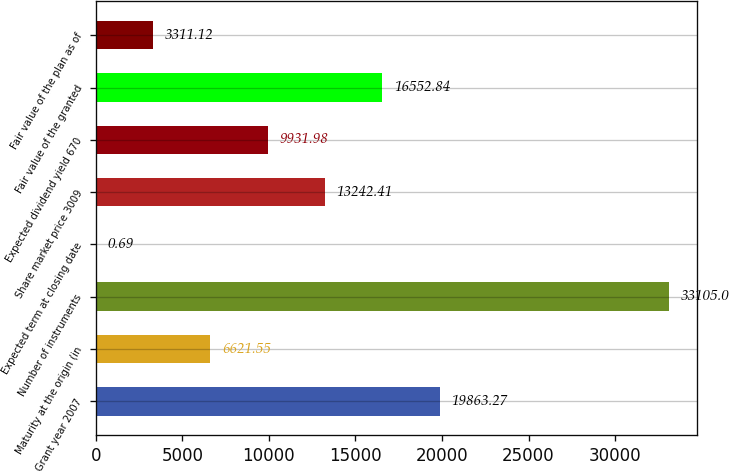<chart> <loc_0><loc_0><loc_500><loc_500><bar_chart><fcel>Grant year 2007<fcel>Maturity at the origin (in<fcel>Number of instruments<fcel>Expected term at closing date<fcel>Share market price 3009<fcel>Expected dividend yield 670<fcel>Fair value of the granted<fcel>Fair value of the plan as of<nl><fcel>19863.3<fcel>6621.55<fcel>33105<fcel>0.69<fcel>13242.4<fcel>9931.98<fcel>16552.8<fcel>3311.12<nl></chart> 